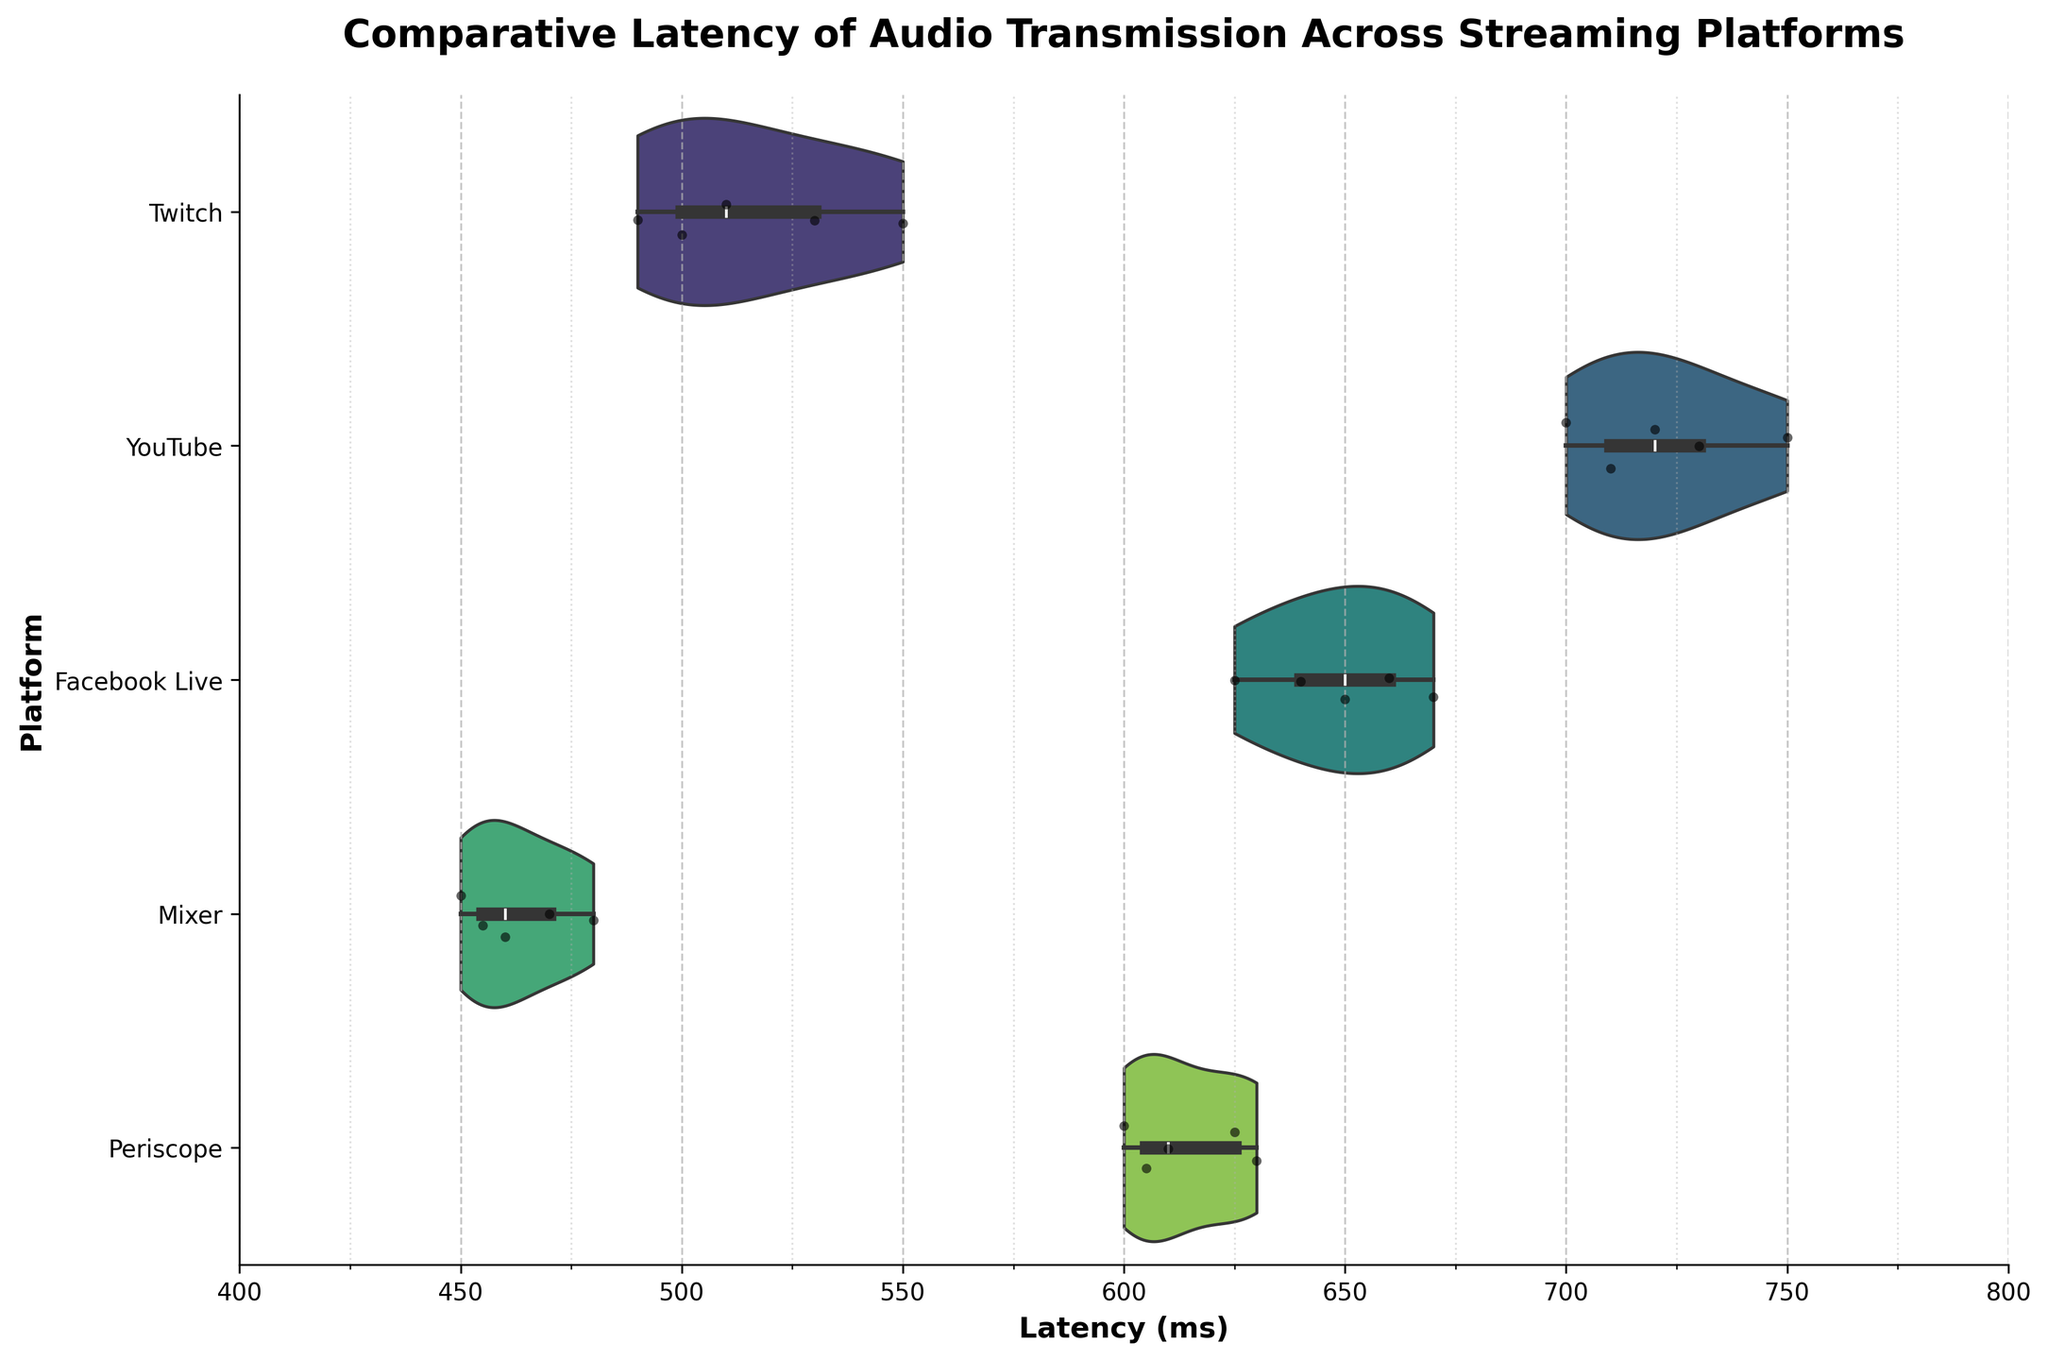What's the title of the plot? The title is displayed at the top of the plot and reads: "Comparative Latency of Audio Transmission Across Streaming Platforms."
Answer: Comparative Latency of Audio Transmission Across Streaming Platforms What is the range of the x-axis? The x-axis is labeled 'Latency (ms)' and ranges from 400 ms to 800 ms as indicated by the axis limits and tick marks.
Answer: 400 to 800 ms Which platform shows the highest median latency? By observing the inner box plot in each violin plot, YouTube shows the highest median latency indicated by the thick band near the center of the distribution.
Answer: YouTube How many major grid lines are on the x-axis? The x-axis major grid lines are visible and start at 400 ms, with increments of 50 ms, up to 800 ms, thus counting to find the total.
Answer: 9 Which platform has the most compact latency distribution? The compactness of latency distribution is determined by the width of the violin plot. Mixer shows the most compact distribution as its violin plot appears narrowest compared to others.
Answer: Mixer Which platforms have their maximum latencies above 700 ms? By observing the violin plots, YouTube and Facebook Live have maximum latencies (the top ends of the violin plots) that extend above 700 ms.
Answer: YouTube, Facebook Live What’s the approximate range of latency values for Periscope? The Periscope violin plot spans the x-axis from around 600 ms to 630 ms.
Answer: 600 to 630 ms Which platform has the lowest minimum latency? By looking at the bottom of each violin plot, Mixer has the lowest minimum latency, starting at slightly below 450 ms.
Answer: Mixer What’s the mean latency for Twitch? Using visual interpretation of the central tendency, the symmetrical shape with respect to the x-axis and most data points clustering around, the mean latency for Twitch appears to be around 515 ms.
Answer: Around 515 ms How does the range of latencies for Facebook Live compare to Twitch? Observing the width of the violin plots, Facebook Live has a range from approximately 625 ms to 670 ms while Twitch ranges from approximately 490 ms to 550 ms indicating Facebook Live's range is higher.
Answer: Facebook Live's range is higher 